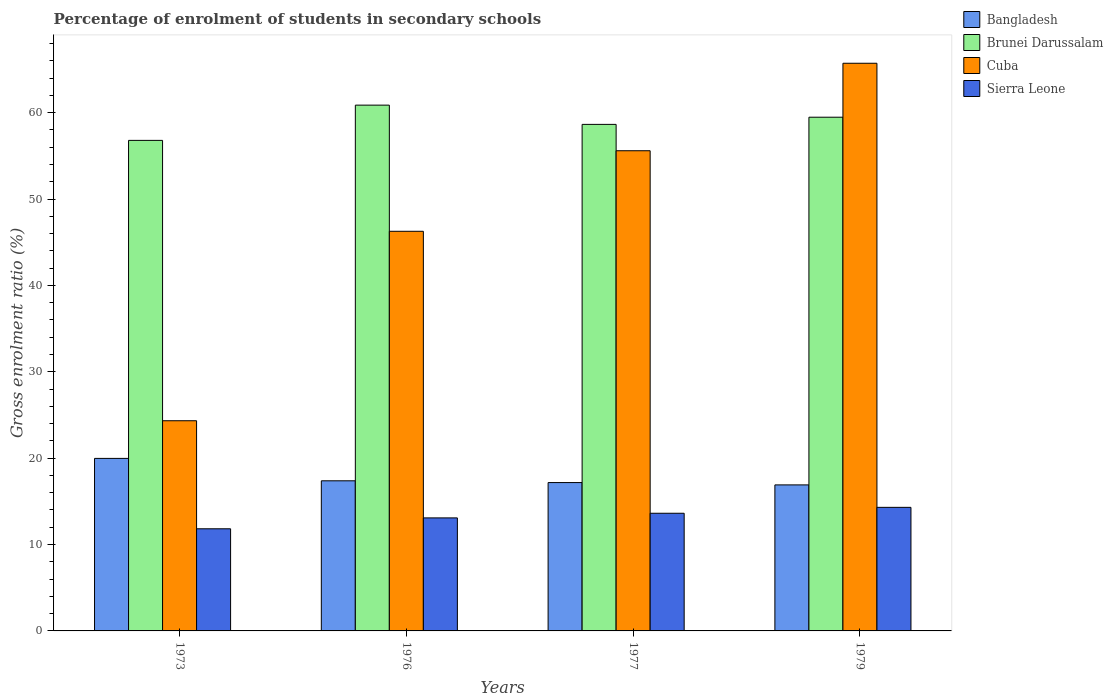How many different coloured bars are there?
Keep it short and to the point. 4. How many groups of bars are there?
Give a very brief answer. 4. Are the number of bars on each tick of the X-axis equal?
Provide a short and direct response. Yes. How many bars are there on the 3rd tick from the right?
Provide a short and direct response. 4. What is the label of the 3rd group of bars from the left?
Keep it short and to the point. 1977. What is the percentage of students enrolled in secondary schools in Cuba in 1976?
Provide a short and direct response. 46.26. Across all years, what is the maximum percentage of students enrolled in secondary schools in Brunei Darussalam?
Your response must be concise. 60.87. Across all years, what is the minimum percentage of students enrolled in secondary schools in Brunei Darussalam?
Your response must be concise. 56.79. In which year was the percentage of students enrolled in secondary schools in Sierra Leone minimum?
Provide a short and direct response. 1973. What is the total percentage of students enrolled in secondary schools in Brunei Darussalam in the graph?
Give a very brief answer. 235.76. What is the difference between the percentage of students enrolled in secondary schools in Cuba in 1973 and that in 1979?
Keep it short and to the point. -41.38. What is the difference between the percentage of students enrolled in secondary schools in Cuba in 1977 and the percentage of students enrolled in secondary schools in Sierra Leone in 1973?
Your response must be concise. 43.76. What is the average percentage of students enrolled in secondary schools in Sierra Leone per year?
Make the answer very short. 13.21. In the year 1979, what is the difference between the percentage of students enrolled in secondary schools in Cuba and percentage of students enrolled in secondary schools in Brunei Darussalam?
Your answer should be compact. 6.25. What is the ratio of the percentage of students enrolled in secondary schools in Sierra Leone in 1973 to that in 1977?
Your answer should be compact. 0.87. Is the difference between the percentage of students enrolled in secondary schools in Cuba in 1977 and 1979 greater than the difference between the percentage of students enrolled in secondary schools in Brunei Darussalam in 1977 and 1979?
Offer a terse response. No. What is the difference between the highest and the second highest percentage of students enrolled in secondary schools in Brunei Darussalam?
Ensure brevity in your answer.  1.4. What is the difference between the highest and the lowest percentage of students enrolled in secondary schools in Brunei Darussalam?
Keep it short and to the point. 4.08. Is the sum of the percentage of students enrolled in secondary schools in Brunei Darussalam in 1973 and 1976 greater than the maximum percentage of students enrolled in secondary schools in Cuba across all years?
Ensure brevity in your answer.  Yes. What does the 1st bar from the left in 1973 represents?
Keep it short and to the point. Bangladesh. What does the 1st bar from the right in 1973 represents?
Give a very brief answer. Sierra Leone. Is it the case that in every year, the sum of the percentage of students enrolled in secondary schools in Bangladesh and percentage of students enrolled in secondary schools in Cuba is greater than the percentage of students enrolled in secondary schools in Brunei Darussalam?
Make the answer very short. No. What is the difference between two consecutive major ticks on the Y-axis?
Provide a succinct answer. 10. How are the legend labels stacked?
Your answer should be very brief. Vertical. What is the title of the graph?
Provide a short and direct response. Percentage of enrolment of students in secondary schools. Does "Sub-Saharan Africa (developing only)" appear as one of the legend labels in the graph?
Your response must be concise. No. What is the Gross enrolment ratio (%) in Bangladesh in 1973?
Your answer should be very brief. 19.97. What is the Gross enrolment ratio (%) in Brunei Darussalam in 1973?
Provide a succinct answer. 56.79. What is the Gross enrolment ratio (%) of Cuba in 1973?
Give a very brief answer. 24.33. What is the Gross enrolment ratio (%) of Sierra Leone in 1973?
Your answer should be very brief. 11.82. What is the Gross enrolment ratio (%) in Bangladesh in 1976?
Your answer should be compact. 17.38. What is the Gross enrolment ratio (%) of Brunei Darussalam in 1976?
Keep it short and to the point. 60.87. What is the Gross enrolment ratio (%) of Cuba in 1976?
Offer a very short reply. 46.26. What is the Gross enrolment ratio (%) in Sierra Leone in 1976?
Make the answer very short. 13.08. What is the Gross enrolment ratio (%) of Bangladesh in 1977?
Make the answer very short. 17.17. What is the Gross enrolment ratio (%) in Brunei Darussalam in 1977?
Offer a very short reply. 58.64. What is the Gross enrolment ratio (%) of Cuba in 1977?
Your answer should be very brief. 55.59. What is the Gross enrolment ratio (%) in Sierra Leone in 1977?
Make the answer very short. 13.62. What is the Gross enrolment ratio (%) in Bangladesh in 1979?
Provide a succinct answer. 16.9. What is the Gross enrolment ratio (%) in Brunei Darussalam in 1979?
Your answer should be compact. 59.47. What is the Gross enrolment ratio (%) of Cuba in 1979?
Offer a terse response. 65.72. What is the Gross enrolment ratio (%) of Sierra Leone in 1979?
Your response must be concise. 14.3. Across all years, what is the maximum Gross enrolment ratio (%) in Bangladesh?
Ensure brevity in your answer.  19.97. Across all years, what is the maximum Gross enrolment ratio (%) of Brunei Darussalam?
Provide a short and direct response. 60.87. Across all years, what is the maximum Gross enrolment ratio (%) of Cuba?
Your answer should be compact. 65.72. Across all years, what is the maximum Gross enrolment ratio (%) of Sierra Leone?
Ensure brevity in your answer.  14.3. Across all years, what is the minimum Gross enrolment ratio (%) of Bangladesh?
Keep it short and to the point. 16.9. Across all years, what is the minimum Gross enrolment ratio (%) of Brunei Darussalam?
Your answer should be compact. 56.79. Across all years, what is the minimum Gross enrolment ratio (%) of Cuba?
Your answer should be compact. 24.33. Across all years, what is the minimum Gross enrolment ratio (%) of Sierra Leone?
Make the answer very short. 11.82. What is the total Gross enrolment ratio (%) of Bangladesh in the graph?
Offer a terse response. 71.43. What is the total Gross enrolment ratio (%) in Brunei Darussalam in the graph?
Keep it short and to the point. 235.76. What is the total Gross enrolment ratio (%) of Cuba in the graph?
Your answer should be very brief. 191.9. What is the total Gross enrolment ratio (%) in Sierra Leone in the graph?
Your response must be concise. 52.83. What is the difference between the Gross enrolment ratio (%) in Bangladesh in 1973 and that in 1976?
Provide a succinct answer. 2.59. What is the difference between the Gross enrolment ratio (%) in Brunei Darussalam in 1973 and that in 1976?
Your response must be concise. -4.08. What is the difference between the Gross enrolment ratio (%) in Cuba in 1973 and that in 1976?
Ensure brevity in your answer.  -21.93. What is the difference between the Gross enrolment ratio (%) of Sierra Leone in 1973 and that in 1976?
Offer a terse response. -1.26. What is the difference between the Gross enrolment ratio (%) of Bangladesh in 1973 and that in 1977?
Ensure brevity in your answer.  2.8. What is the difference between the Gross enrolment ratio (%) of Brunei Darussalam in 1973 and that in 1977?
Keep it short and to the point. -1.85. What is the difference between the Gross enrolment ratio (%) of Cuba in 1973 and that in 1977?
Your response must be concise. -31.26. What is the difference between the Gross enrolment ratio (%) in Sierra Leone in 1973 and that in 1977?
Offer a very short reply. -1.8. What is the difference between the Gross enrolment ratio (%) of Bangladesh in 1973 and that in 1979?
Give a very brief answer. 3.07. What is the difference between the Gross enrolment ratio (%) of Brunei Darussalam in 1973 and that in 1979?
Your answer should be very brief. -2.68. What is the difference between the Gross enrolment ratio (%) of Cuba in 1973 and that in 1979?
Keep it short and to the point. -41.38. What is the difference between the Gross enrolment ratio (%) of Sierra Leone in 1973 and that in 1979?
Provide a succinct answer. -2.48. What is the difference between the Gross enrolment ratio (%) of Bangladesh in 1976 and that in 1977?
Ensure brevity in your answer.  0.2. What is the difference between the Gross enrolment ratio (%) of Brunei Darussalam in 1976 and that in 1977?
Provide a short and direct response. 2.23. What is the difference between the Gross enrolment ratio (%) in Cuba in 1976 and that in 1977?
Provide a succinct answer. -9.32. What is the difference between the Gross enrolment ratio (%) of Sierra Leone in 1976 and that in 1977?
Your answer should be very brief. -0.54. What is the difference between the Gross enrolment ratio (%) in Bangladesh in 1976 and that in 1979?
Keep it short and to the point. 0.47. What is the difference between the Gross enrolment ratio (%) of Brunei Darussalam in 1976 and that in 1979?
Provide a succinct answer. 1.4. What is the difference between the Gross enrolment ratio (%) of Cuba in 1976 and that in 1979?
Ensure brevity in your answer.  -19.45. What is the difference between the Gross enrolment ratio (%) of Sierra Leone in 1976 and that in 1979?
Offer a terse response. -1.22. What is the difference between the Gross enrolment ratio (%) in Bangladesh in 1977 and that in 1979?
Provide a short and direct response. 0.27. What is the difference between the Gross enrolment ratio (%) in Brunei Darussalam in 1977 and that in 1979?
Provide a succinct answer. -0.83. What is the difference between the Gross enrolment ratio (%) of Cuba in 1977 and that in 1979?
Keep it short and to the point. -10.13. What is the difference between the Gross enrolment ratio (%) in Sierra Leone in 1977 and that in 1979?
Give a very brief answer. -0.68. What is the difference between the Gross enrolment ratio (%) in Bangladesh in 1973 and the Gross enrolment ratio (%) in Brunei Darussalam in 1976?
Your answer should be very brief. -40.89. What is the difference between the Gross enrolment ratio (%) of Bangladesh in 1973 and the Gross enrolment ratio (%) of Cuba in 1976?
Your response must be concise. -26.29. What is the difference between the Gross enrolment ratio (%) of Bangladesh in 1973 and the Gross enrolment ratio (%) of Sierra Leone in 1976?
Your answer should be very brief. 6.89. What is the difference between the Gross enrolment ratio (%) of Brunei Darussalam in 1973 and the Gross enrolment ratio (%) of Cuba in 1976?
Give a very brief answer. 10.52. What is the difference between the Gross enrolment ratio (%) in Brunei Darussalam in 1973 and the Gross enrolment ratio (%) in Sierra Leone in 1976?
Provide a succinct answer. 43.7. What is the difference between the Gross enrolment ratio (%) of Cuba in 1973 and the Gross enrolment ratio (%) of Sierra Leone in 1976?
Keep it short and to the point. 11.25. What is the difference between the Gross enrolment ratio (%) in Bangladesh in 1973 and the Gross enrolment ratio (%) in Brunei Darussalam in 1977?
Offer a terse response. -38.67. What is the difference between the Gross enrolment ratio (%) in Bangladesh in 1973 and the Gross enrolment ratio (%) in Cuba in 1977?
Offer a very short reply. -35.62. What is the difference between the Gross enrolment ratio (%) of Bangladesh in 1973 and the Gross enrolment ratio (%) of Sierra Leone in 1977?
Provide a succinct answer. 6.35. What is the difference between the Gross enrolment ratio (%) in Brunei Darussalam in 1973 and the Gross enrolment ratio (%) in Cuba in 1977?
Your answer should be compact. 1.2. What is the difference between the Gross enrolment ratio (%) of Brunei Darussalam in 1973 and the Gross enrolment ratio (%) of Sierra Leone in 1977?
Your answer should be compact. 43.17. What is the difference between the Gross enrolment ratio (%) in Cuba in 1973 and the Gross enrolment ratio (%) in Sierra Leone in 1977?
Your response must be concise. 10.71. What is the difference between the Gross enrolment ratio (%) in Bangladesh in 1973 and the Gross enrolment ratio (%) in Brunei Darussalam in 1979?
Your answer should be very brief. -39.5. What is the difference between the Gross enrolment ratio (%) in Bangladesh in 1973 and the Gross enrolment ratio (%) in Cuba in 1979?
Your response must be concise. -45.74. What is the difference between the Gross enrolment ratio (%) of Bangladesh in 1973 and the Gross enrolment ratio (%) of Sierra Leone in 1979?
Offer a very short reply. 5.67. What is the difference between the Gross enrolment ratio (%) of Brunei Darussalam in 1973 and the Gross enrolment ratio (%) of Cuba in 1979?
Keep it short and to the point. -8.93. What is the difference between the Gross enrolment ratio (%) of Brunei Darussalam in 1973 and the Gross enrolment ratio (%) of Sierra Leone in 1979?
Offer a terse response. 42.48. What is the difference between the Gross enrolment ratio (%) in Cuba in 1973 and the Gross enrolment ratio (%) in Sierra Leone in 1979?
Offer a very short reply. 10.03. What is the difference between the Gross enrolment ratio (%) in Bangladesh in 1976 and the Gross enrolment ratio (%) in Brunei Darussalam in 1977?
Make the answer very short. -41.26. What is the difference between the Gross enrolment ratio (%) of Bangladesh in 1976 and the Gross enrolment ratio (%) of Cuba in 1977?
Keep it short and to the point. -38.21. What is the difference between the Gross enrolment ratio (%) in Bangladesh in 1976 and the Gross enrolment ratio (%) in Sierra Leone in 1977?
Keep it short and to the point. 3.76. What is the difference between the Gross enrolment ratio (%) of Brunei Darussalam in 1976 and the Gross enrolment ratio (%) of Cuba in 1977?
Offer a terse response. 5.28. What is the difference between the Gross enrolment ratio (%) in Brunei Darussalam in 1976 and the Gross enrolment ratio (%) in Sierra Leone in 1977?
Your answer should be very brief. 47.25. What is the difference between the Gross enrolment ratio (%) in Cuba in 1976 and the Gross enrolment ratio (%) in Sierra Leone in 1977?
Ensure brevity in your answer.  32.64. What is the difference between the Gross enrolment ratio (%) in Bangladesh in 1976 and the Gross enrolment ratio (%) in Brunei Darussalam in 1979?
Your answer should be compact. -42.09. What is the difference between the Gross enrolment ratio (%) of Bangladesh in 1976 and the Gross enrolment ratio (%) of Cuba in 1979?
Your answer should be compact. -48.34. What is the difference between the Gross enrolment ratio (%) in Bangladesh in 1976 and the Gross enrolment ratio (%) in Sierra Leone in 1979?
Give a very brief answer. 3.07. What is the difference between the Gross enrolment ratio (%) of Brunei Darussalam in 1976 and the Gross enrolment ratio (%) of Cuba in 1979?
Your answer should be compact. -4.85. What is the difference between the Gross enrolment ratio (%) in Brunei Darussalam in 1976 and the Gross enrolment ratio (%) in Sierra Leone in 1979?
Ensure brevity in your answer.  46.56. What is the difference between the Gross enrolment ratio (%) in Cuba in 1976 and the Gross enrolment ratio (%) in Sierra Leone in 1979?
Make the answer very short. 31.96. What is the difference between the Gross enrolment ratio (%) of Bangladesh in 1977 and the Gross enrolment ratio (%) of Brunei Darussalam in 1979?
Ensure brevity in your answer.  -42.3. What is the difference between the Gross enrolment ratio (%) in Bangladesh in 1977 and the Gross enrolment ratio (%) in Cuba in 1979?
Make the answer very short. -48.54. What is the difference between the Gross enrolment ratio (%) in Bangladesh in 1977 and the Gross enrolment ratio (%) in Sierra Leone in 1979?
Your answer should be compact. 2.87. What is the difference between the Gross enrolment ratio (%) in Brunei Darussalam in 1977 and the Gross enrolment ratio (%) in Cuba in 1979?
Offer a very short reply. -7.08. What is the difference between the Gross enrolment ratio (%) of Brunei Darussalam in 1977 and the Gross enrolment ratio (%) of Sierra Leone in 1979?
Keep it short and to the point. 44.33. What is the difference between the Gross enrolment ratio (%) in Cuba in 1977 and the Gross enrolment ratio (%) in Sierra Leone in 1979?
Make the answer very short. 41.28. What is the average Gross enrolment ratio (%) in Bangladesh per year?
Your answer should be compact. 17.86. What is the average Gross enrolment ratio (%) of Brunei Darussalam per year?
Provide a succinct answer. 58.94. What is the average Gross enrolment ratio (%) in Cuba per year?
Your answer should be very brief. 47.97. What is the average Gross enrolment ratio (%) in Sierra Leone per year?
Give a very brief answer. 13.21. In the year 1973, what is the difference between the Gross enrolment ratio (%) in Bangladesh and Gross enrolment ratio (%) in Brunei Darussalam?
Ensure brevity in your answer.  -36.81. In the year 1973, what is the difference between the Gross enrolment ratio (%) in Bangladesh and Gross enrolment ratio (%) in Cuba?
Your answer should be very brief. -4.36. In the year 1973, what is the difference between the Gross enrolment ratio (%) in Bangladesh and Gross enrolment ratio (%) in Sierra Leone?
Your response must be concise. 8.15. In the year 1973, what is the difference between the Gross enrolment ratio (%) in Brunei Darussalam and Gross enrolment ratio (%) in Cuba?
Make the answer very short. 32.46. In the year 1973, what is the difference between the Gross enrolment ratio (%) of Brunei Darussalam and Gross enrolment ratio (%) of Sierra Leone?
Ensure brevity in your answer.  44.96. In the year 1973, what is the difference between the Gross enrolment ratio (%) of Cuba and Gross enrolment ratio (%) of Sierra Leone?
Offer a terse response. 12.51. In the year 1976, what is the difference between the Gross enrolment ratio (%) of Bangladesh and Gross enrolment ratio (%) of Brunei Darussalam?
Your response must be concise. -43.49. In the year 1976, what is the difference between the Gross enrolment ratio (%) in Bangladesh and Gross enrolment ratio (%) in Cuba?
Your answer should be compact. -28.89. In the year 1976, what is the difference between the Gross enrolment ratio (%) of Bangladesh and Gross enrolment ratio (%) of Sierra Leone?
Your answer should be compact. 4.29. In the year 1976, what is the difference between the Gross enrolment ratio (%) in Brunei Darussalam and Gross enrolment ratio (%) in Cuba?
Your response must be concise. 14.6. In the year 1976, what is the difference between the Gross enrolment ratio (%) in Brunei Darussalam and Gross enrolment ratio (%) in Sierra Leone?
Your answer should be very brief. 47.78. In the year 1976, what is the difference between the Gross enrolment ratio (%) of Cuba and Gross enrolment ratio (%) of Sierra Leone?
Provide a short and direct response. 33.18. In the year 1977, what is the difference between the Gross enrolment ratio (%) in Bangladesh and Gross enrolment ratio (%) in Brunei Darussalam?
Keep it short and to the point. -41.47. In the year 1977, what is the difference between the Gross enrolment ratio (%) of Bangladesh and Gross enrolment ratio (%) of Cuba?
Your response must be concise. -38.42. In the year 1977, what is the difference between the Gross enrolment ratio (%) in Bangladesh and Gross enrolment ratio (%) in Sierra Leone?
Offer a terse response. 3.55. In the year 1977, what is the difference between the Gross enrolment ratio (%) in Brunei Darussalam and Gross enrolment ratio (%) in Cuba?
Keep it short and to the point. 3.05. In the year 1977, what is the difference between the Gross enrolment ratio (%) of Brunei Darussalam and Gross enrolment ratio (%) of Sierra Leone?
Make the answer very short. 45.02. In the year 1977, what is the difference between the Gross enrolment ratio (%) of Cuba and Gross enrolment ratio (%) of Sierra Leone?
Provide a succinct answer. 41.97. In the year 1979, what is the difference between the Gross enrolment ratio (%) in Bangladesh and Gross enrolment ratio (%) in Brunei Darussalam?
Give a very brief answer. -42.57. In the year 1979, what is the difference between the Gross enrolment ratio (%) in Bangladesh and Gross enrolment ratio (%) in Cuba?
Offer a terse response. -48.81. In the year 1979, what is the difference between the Gross enrolment ratio (%) of Bangladesh and Gross enrolment ratio (%) of Sierra Leone?
Offer a terse response. 2.6. In the year 1979, what is the difference between the Gross enrolment ratio (%) of Brunei Darussalam and Gross enrolment ratio (%) of Cuba?
Offer a very short reply. -6.25. In the year 1979, what is the difference between the Gross enrolment ratio (%) of Brunei Darussalam and Gross enrolment ratio (%) of Sierra Leone?
Your response must be concise. 45.16. In the year 1979, what is the difference between the Gross enrolment ratio (%) in Cuba and Gross enrolment ratio (%) in Sierra Leone?
Provide a succinct answer. 51.41. What is the ratio of the Gross enrolment ratio (%) in Bangladesh in 1973 to that in 1976?
Keep it short and to the point. 1.15. What is the ratio of the Gross enrolment ratio (%) of Brunei Darussalam in 1973 to that in 1976?
Keep it short and to the point. 0.93. What is the ratio of the Gross enrolment ratio (%) in Cuba in 1973 to that in 1976?
Keep it short and to the point. 0.53. What is the ratio of the Gross enrolment ratio (%) in Sierra Leone in 1973 to that in 1976?
Your answer should be compact. 0.9. What is the ratio of the Gross enrolment ratio (%) in Bangladesh in 1973 to that in 1977?
Keep it short and to the point. 1.16. What is the ratio of the Gross enrolment ratio (%) in Brunei Darussalam in 1973 to that in 1977?
Your answer should be very brief. 0.97. What is the ratio of the Gross enrolment ratio (%) in Cuba in 1973 to that in 1977?
Your response must be concise. 0.44. What is the ratio of the Gross enrolment ratio (%) of Sierra Leone in 1973 to that in 1977?
Ensure brevity in your answer.  0.87. What is the ratio of the Gross enrolment ratio (%) of Bangladesh in 1973 to that in 1979?
Make the answer very short. 1.18. What is the ratio of the Gross enrolment ratio (%) of Brunei Darussalam in 1973 to that in 1979?
Your answer should be compact. 0.95. What is the ratio of the Gross enrolment ratio (%) in Cuba in 1973 to that in 1979?
Your response must be concise. 0.37. What is the ratio of the Gross enrolment ratio (%) of Sierra Leone in 1973 to that in 1979?
Your response must be concise. 0.83. What is the ratio of the Gross enrolment ratio (%) in Bangladesh in 1976 to that in 1977?
Your answer should be very brief. 1.01. What is the ratio of the Gross enrolment ratio (%) of Brunei Darussalam in 1976 to that in 1977?
Give a very brief answer. 1.04. What is the ratio of the Gross enrolment ratio (%) in Cuba in 1976 to that in 1977?
Your response must be concise. 0.83. What is the ratio of the Gross enrolment ratio (%) of Sierra Leone in 1976 to that in 1977?
Provide a short and direct response. 0.96. What is the ratio of the Gross enrolment ratio (%) of Bangladesh in 1976 to that in 1979?
Provide a short and direct response. 1.03. What is the ratio of the Gross enrolment ratio (%) of Brunei Darussalam in 1976 to that in 1979?
Make the answer very short. 1.02. What is the ratio of the Gross enrolment ratio (%) in Cuba in 1976 to that in 1979?
Offer a very short reply. 0.7. What is the ratio of the Gross enrolment ratio (%) in Sierra Leone in 1976 to that in 1979?
Give a very brief answer. 0.91. What is the ratio of the Gross enrolment ratio (%) of Bangladesh in 1977 to that in 1979?
Provide a succinct answer. 1.02. What is the ratio of the Gross enrolment ratio (%) in Brunei Darussalam in 1977 to that in 1979?
Make the answer very short. 0.99. What is the ratio of the Gross enrolment ratio (%) in Cuba in 1977 to that in 1979?
Offer a very short reply. 0.85. What is the ratio of the Gross enrolment ratio (%) of Sierra Leone in 1977 to that in 1979?
Provide a short and direct response. 0.95. What is the difference between the highest and the second highest Gross enrolment ratio (%) of Bangladesh?
Ensure brevity in your answer.  2.59. What is the difference between the highest and the second highest Gross enrolment ratio (%) of Brunei Darussalam?
Your answer should be compact. 1.4. What is the difference between the highest and the second highest Gross enrolment ratio (%) in Cuba?
Your answer should be very brief. 10.13. What is the difference between the highest and the second highest Gross enrolment ratio (%) in Sierra Leone?
Keep it short and to the point. 0.68. What is the difference between the highest and the lowest Gross enrolment ratio (%) in Bangladesh?
Make the answer very short. 3.07. What is the difference between the highest and the lowest Gross enrolment ratio (%) of Brunei Darussalam?
Offer a terse response. 4.08. What is the difference between the highest and the lowest Gross enrolment ratio (%) of Cuba?
Your answer should be compact. 41.38. What is the difference between the highest and the lowest Gross enrolment ratio (%) in Sierra Leone?
Make the answer very short. 2.48. 